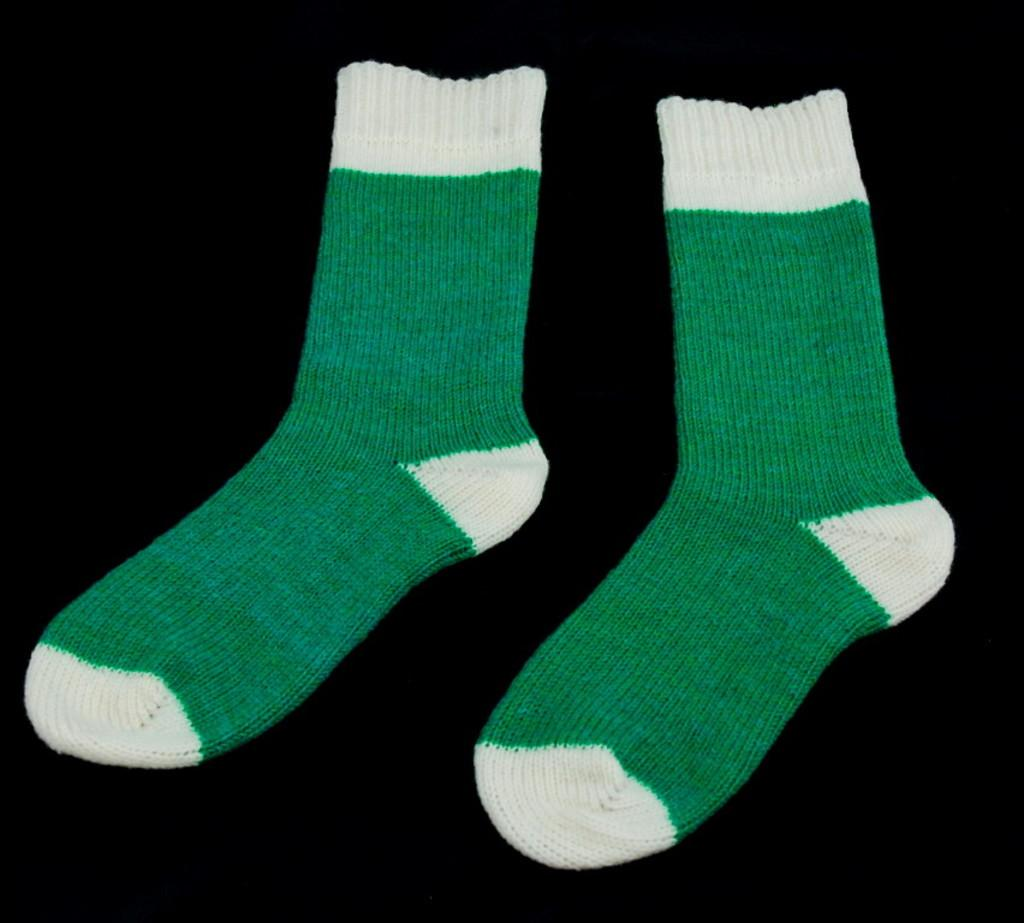What objects are present in the image? There are two socks in the image. Can you describe the colors of the socks? The socks are green and white in color. Can you see any ducks swimming in the ocean near the socks in the image? There are no ducks or ocean present in the image; it only features two socks. 